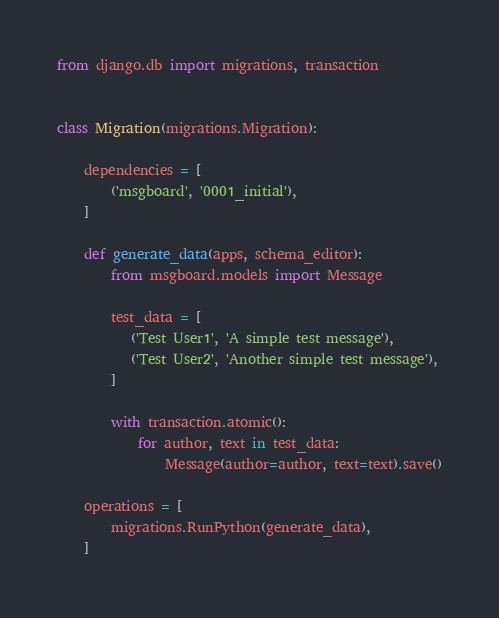Convert code to text. <code><loc_0><loc_0><loc_500><loc_500><_Python_>from django.db import migrations, transaction


class Migration(migrations.Migration):

    dependencies = [
        ('msgboard', '0001_initial'),
    ]

    def generate_data(apps, schema_editor):
        from msgboard.models import Message

        test_data = [
           ('Test User1', 'A simple test message'),
           ('Test User2', 'Another simple test message'),
        ]

        with transaction.atomic():
            for author, text in test_data:
                Message(author=author, text=text).save()

    operations = [
        migrations.RunPython(generate_data),
    ]
</code> 